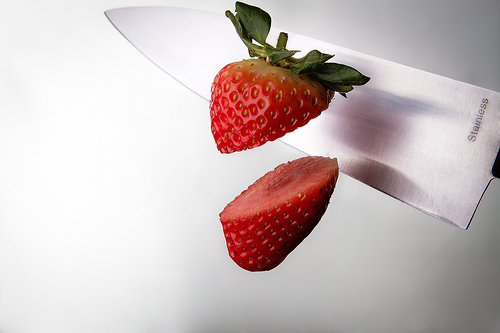<image>
Can you confirm if the strawberry is behind the knife? No. The strawberry is not behind the knife. From this viewpoint, the strawberry appears to be positioned elsewhere in the scene. Where is the leaf slice in relation to the other slice? Is it to the right of the other slice? No. The leaf slice is not to the right of the other slice. The horizontal positioning shows a different relationship. Is there a knife in front of the strawberry? No. The knife is not in front of the strawberry. The spatial positioning shows a different relationship between these objects. 